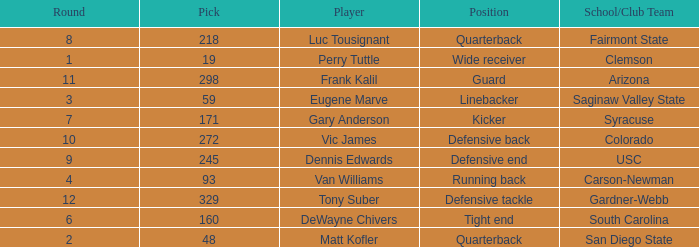Who plays linebacker? Eugene Marve. 